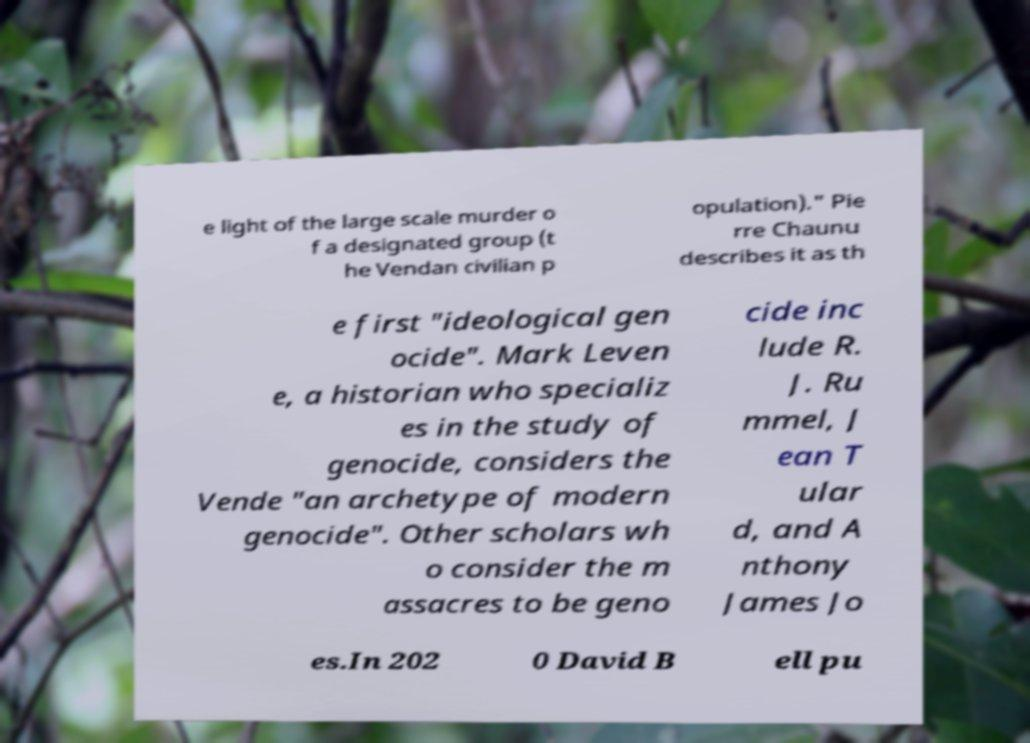What messages or text are displayed in this image? I need them in a readable, typed format. e light of the large scale murder o f a designated group (t he Vendan civilian p opulation)." Pie rre Chaunu describes it as th e first "ideological gen ocide". Mark Leven e, a historian who specializ es in the study of genocide, considers the Vende "an archetype of modern genocide". Other scholars wh o consider the m assacres to be geno cide inc lude R. J. Ru mmel, J ean T ular d, and A nthony James Jo es.In 202 0 David B ell pu 